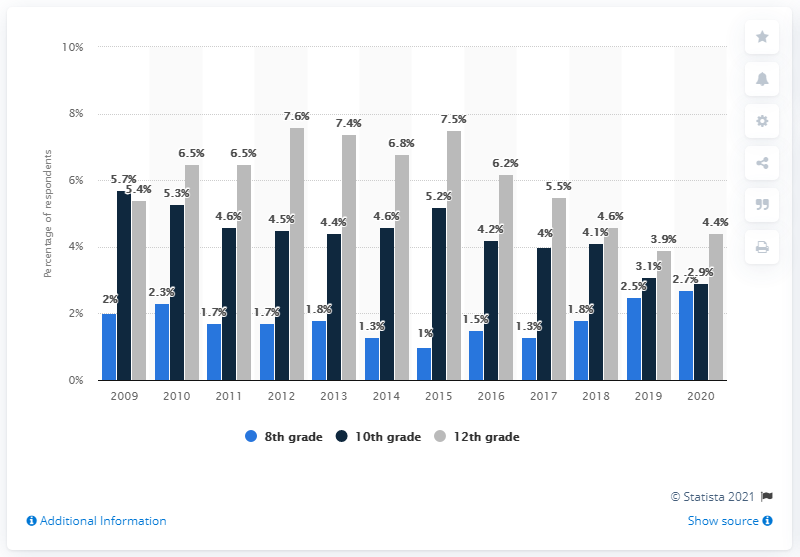Highlight a few significant elements in this photo. In the past year, 4.4% of 12th grade students reported trying Adderall. In 2012, Adderall was most commonly used by 12th graders. 